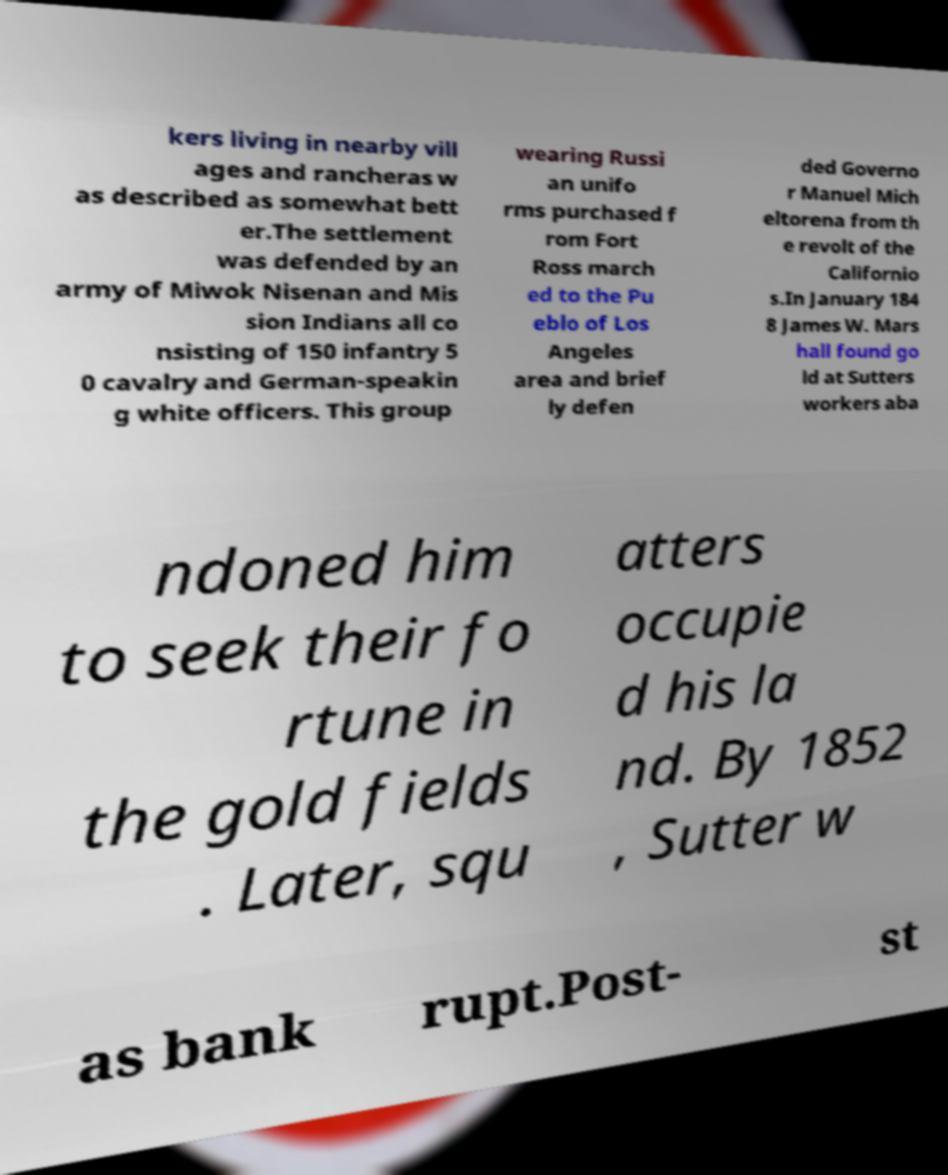What messages or text are displayed in this image? I need them in a readable, typed format. kers living in nearby vill ages and rancheras w as described as somewhat bett er.The settlement was defended by an army of Miwok Nisenan and Mis sion Indians all co nsisting of 150 infantry 5 0 cavalry and German-speakin g white officers. This group wearing Russi an unifo rms purchased f rom Fort Ross march ed to the Pu eblo of Los Angeles area and brief ly defen ded Governo r Manuel Mich eltorena from th e revolt of the Californio s.In January 184 8 James W. Mars hall found go ld at Sutters workers aba ndoned him to seek their fo rtune in the gold fields . Later, squ atters occupie d his la nd. By 1852 , Sutter w as bank rupt.Post- st 